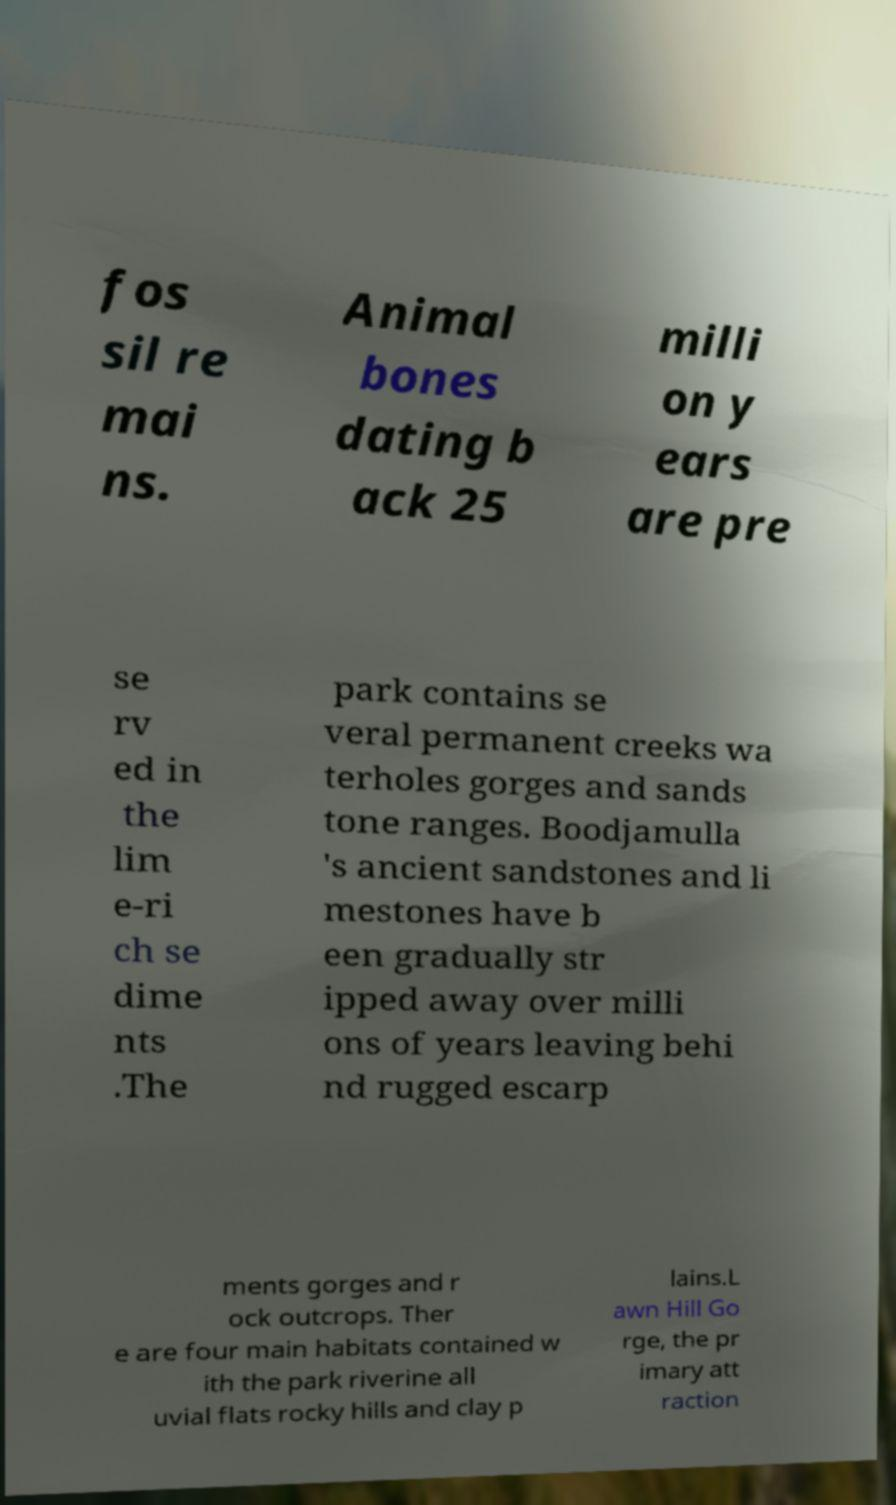Can you accurately transcribe the text from the provided image for me? fos sil re mai ns. Animal bones dating b ack 25 milli on y ears are pre se rv ed in the lim e-ri ch se dime nts .The park contains se veral permanent creeks wa terholes gorges and sands tone ranges. Boodjamulla 's ancient sandstones and li mestones have b een gradually str ipped away over milli ons of years leaving behi nd rugged escarp ments gorges and r ock outcrops. Ther e are four main habitats contained w ith the park riverine all uvial flats rocky hills and clay p lains.L awn Hill Go rge, the pr imary att raction 